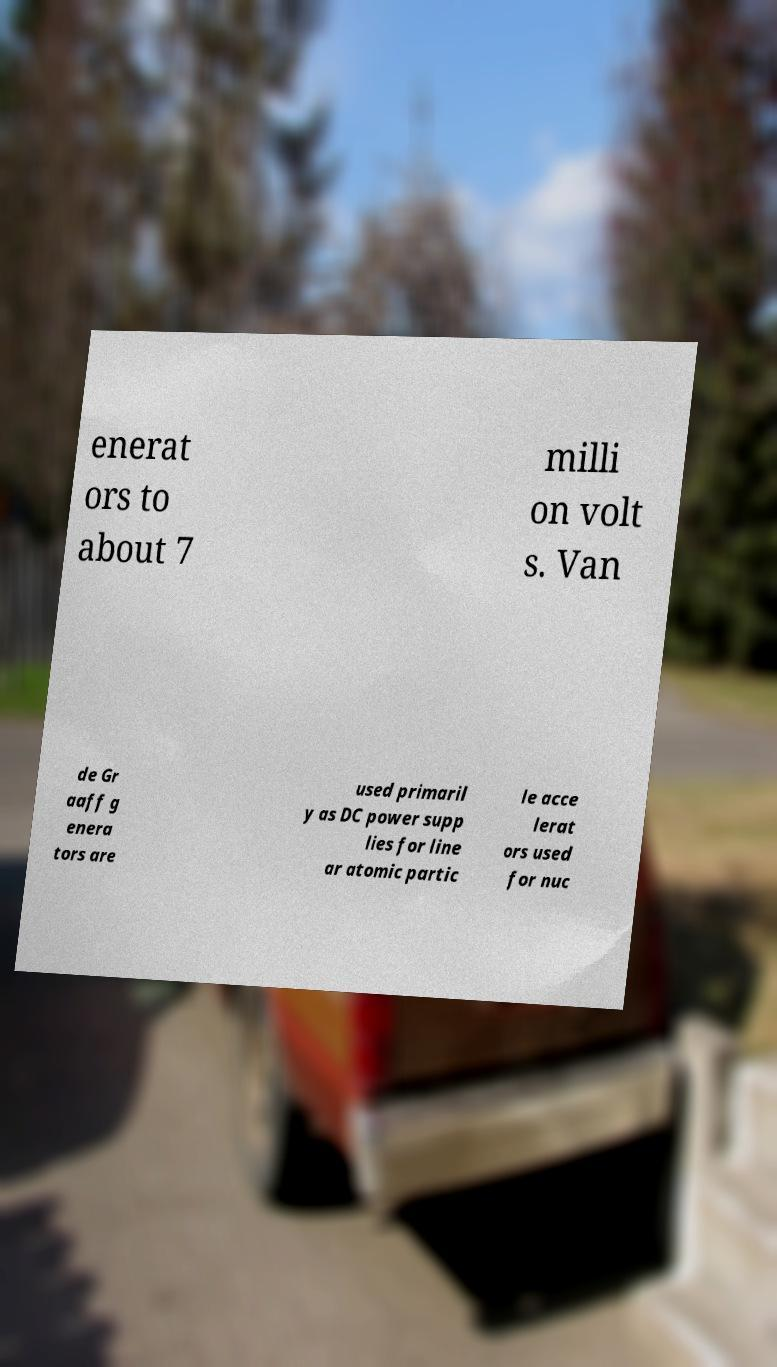There's text embedded in this image that I need extracted. Can you transcribe it verbatim? enerat ors to about 7 milli on volt s. Van de Gr aaff g enera tors are used primaril y as DC power supp lies for line ar atomic partic le acce lerat ors used for nuc 